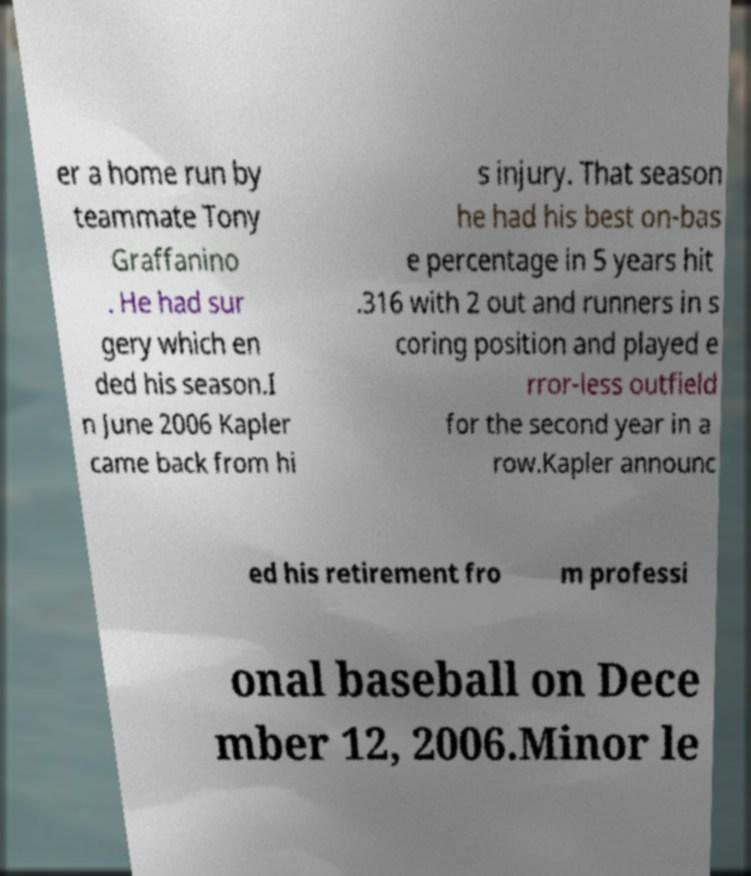Could you extract and type out the text from this image? er a home run by teammate Tony Graffanino . He had sur gery which en ded his season.I n June 2006 Kapler came back from hi s injury. That season he had his best on-bas e percentage in 5 years hit .316 with 2 out and runners in s coring position and played e rror-less outfield for the second year in a row.Kapler announc ed his retirement fro m professi onal baseball on Dece mber 12, 2006.Minor le 